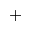<formula> <loc_0><loc_0><loc_500><loc_500>^ { + }</formula> 